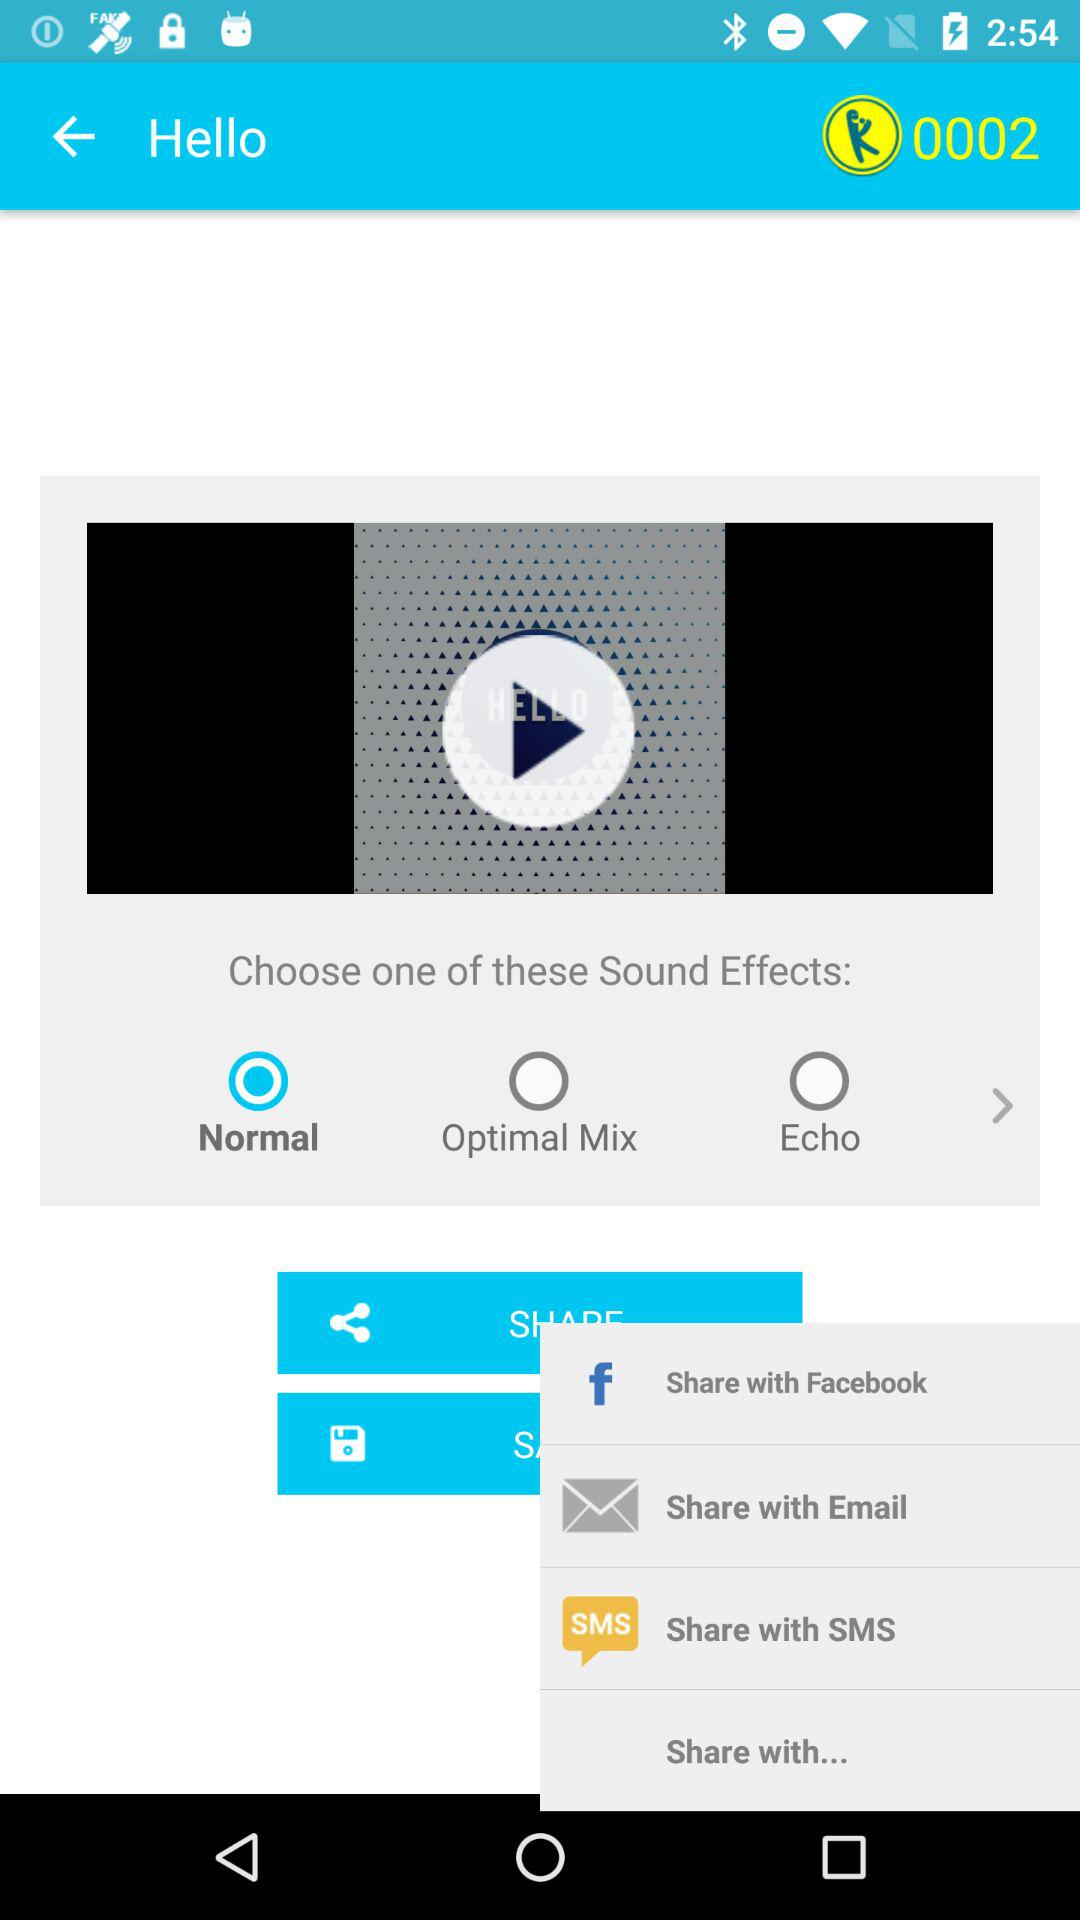What applications are used to share the data? The applications used to share the data are "Facebook", "Email", and "SMS". 